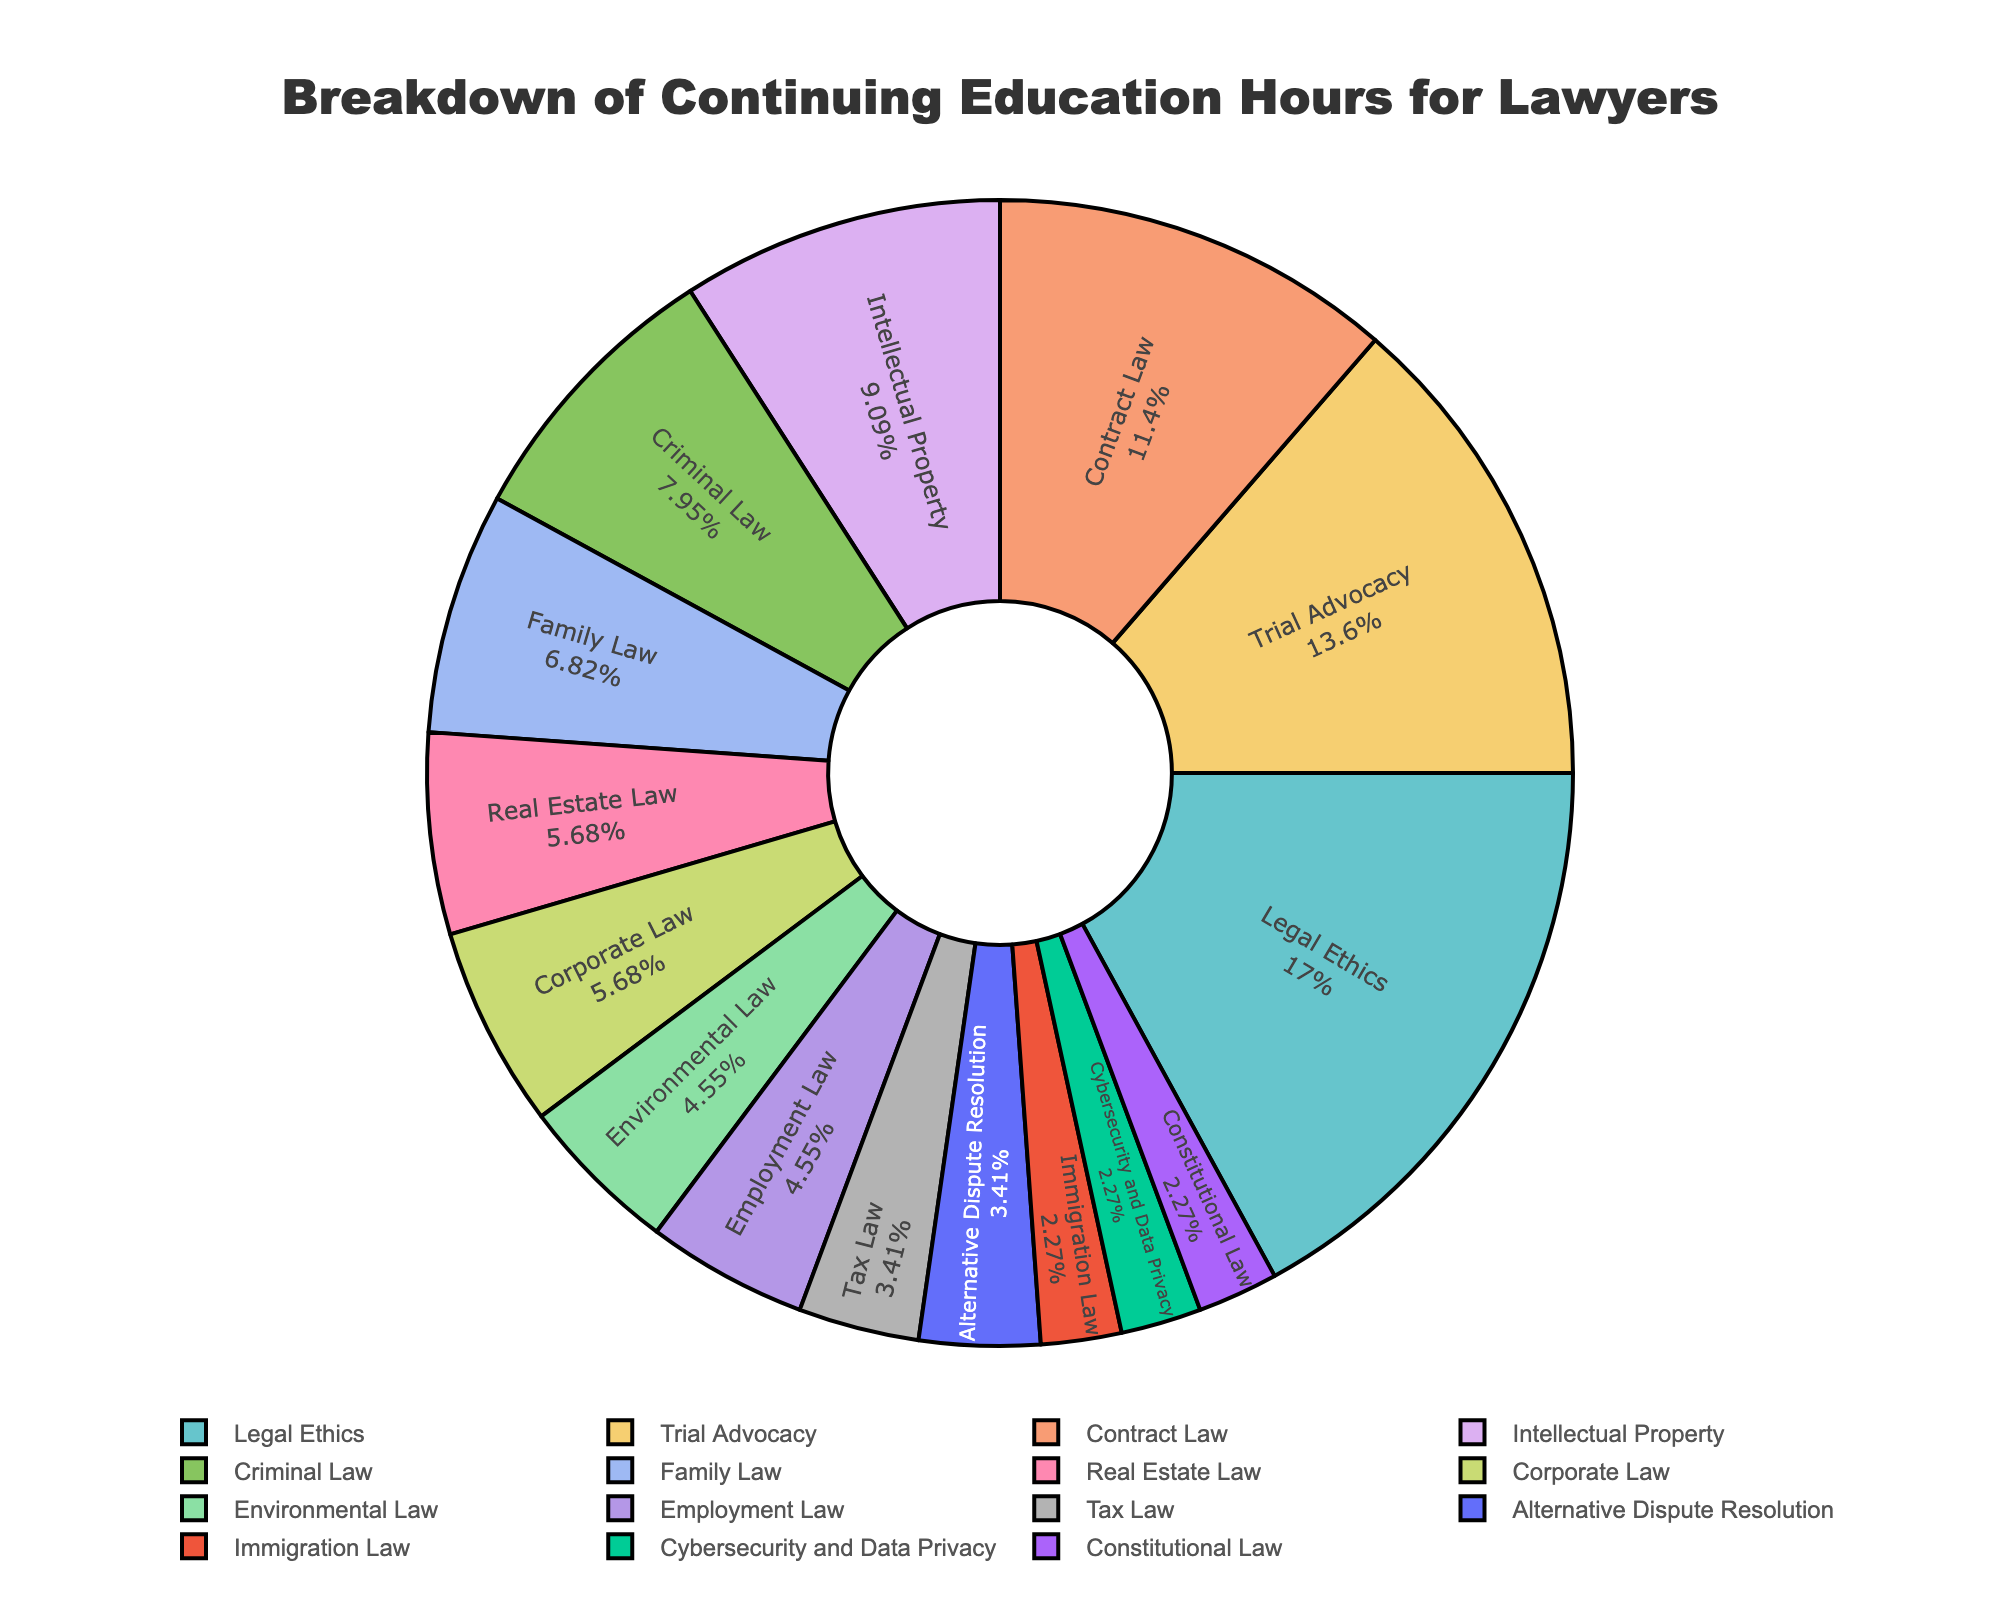What percentage of continuing education hours is dedicated to Legal Ethics? Look at the pie chart segment labeled "Legal Ethics" and note the percentage displayed.
Answer: 19% Which subject has the least number of continuing education hours? Look for the smallest segment in the pie chart and note the subject label.
Answer: Immigration Law and Cybersecurity and Data Privacy How many total continuing education hours are depicted in the pie chart? Sum all the hours listed in the data table: 15 + 12 + 10 + 8 + 7 + 6 + 5 + 5 + 4 + 4 + 3 + 3 + 2 + 2 + 2 = 88 hours
Answer: 88 hours What is the combined percentage of hours for Intellectual Property and Criminal Law? Add the percentages of the segments labeled "Intellectual Property" and "Criminal Law".
Answer: 8% + 7% = 15% Is there a greater percentage of hours allocated to Contract Law or Family Law? Compare the percentages of the segments labeled "Contract Law" and "Family Law".
Answer: Contract Law What is the difference in the number of hours between the subject with the highest and the subject with the lowest hours? Subtract the lowest hours (2 hours) from the highest hours (15 hours).
Answer: 13 hours How many subjects have 5 or fewer continuing education hours? Count the pie chart segments representing subjects with 5 or fewer hours (Real Estate Law, Corporate Law, Environmental Law, Employment Law, Tax Law, Alternative Dispute Resolution, Immigration Law, Cybersecurity and Data Privacy, Constitutional Law).
Answer: 9 subjects What is the average number of continuing education hours per subject? Total hours = 88; Number of subjects = 15; Divide the total hours by the number of subjects: 88 / 15.
Answer: 5.87 hours Which subjects have an equal number of continuing education hours? Look for segments with the same value; Real Estate Law and Corporate Law each have 5 hours.
Answer: Real Estate Law and Corporate Law How does the number of hours allocated to Trial Advocacy compare to that of Contract Law and Family Law combined? Calculate the combined hours of Contract Law and Family Law (10 + 6) = 16, then compare with Trial Advocacy (12).
Answer: Less than Contract Law and Family Law combined 